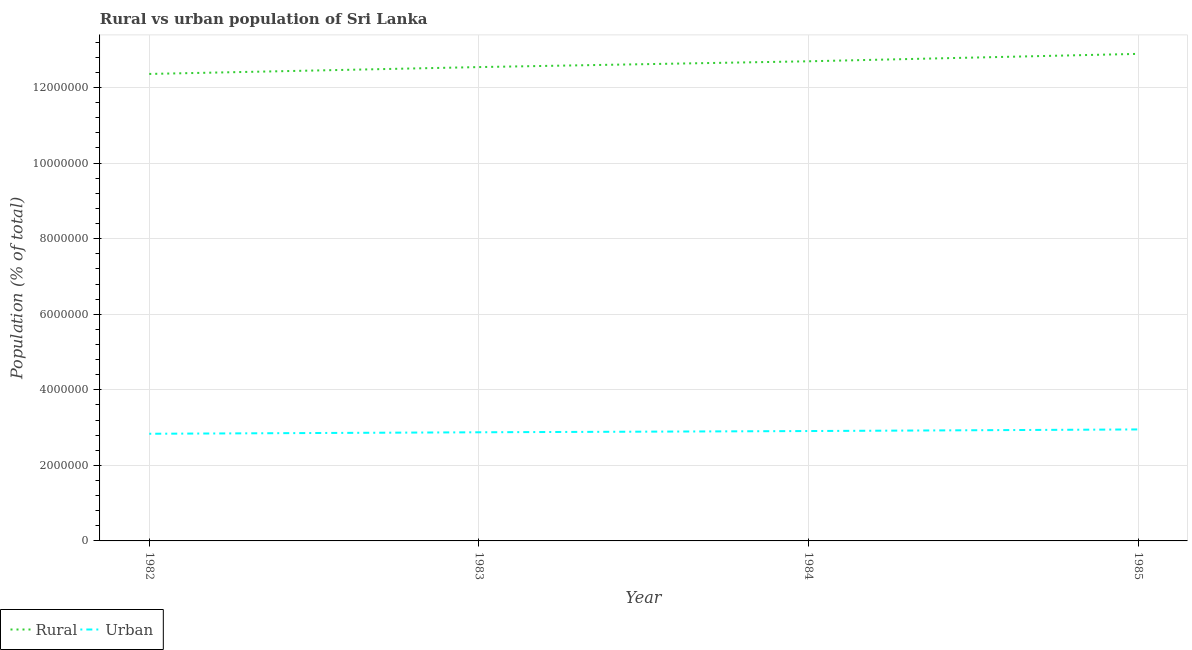Does the line corresponding to urban population density intersect with the line corresponding to rural population density?
Keep it short and to the point. No. What is the rural population density in 1983?
Give a very brief answer. 1.25e+07. Across all years, what is the maximum urban population density?
Make the answer very short. 2.95e+06. Across all years, what is the minimum rural population density?
Ensure brevity in your answer.  1.24e+07. In which year was the rural population density maximum?
Your response must be concise. 1985. What is the total rural population density in the graph?
Your response must be concise. 5.05e+07. What is the difference between the urban population density in 1982 and that in 1983?
Offer a terse response. -3.94e+04. What is the difference between the rural population density in 1985 and the urban population density in 1984?
Ensure brevity in your answer.  9.98e+06. What is the average rural population density per year?
Ensure brevity in your answer.  1.26e+07. In the year 1984, what is the difference between the urban population density and rural population density?
Your response must be concise. -9.79e+06. What is the ratio of the rural population density in 1982 to that in 1983?
Offer a very short reply. 0.99. Is the rural population density in 1983 less than that in 1985?
Provide a succinct answer. Yes. Is the difference between the rural population density in 1983 and 1985 greater than the difference between the urban population density in 1983 and 1985?
Provide a succinct answer. No. What is the difference between the highest and the second highest urban population density?
Offer a very short reply. 4.26e+04. What is the difference between the highest and the lowest urban population density?
Your answer should be compact. 1.15e+05. In how many years, is the urban population density greater than the average urban population density taken over all years?
Give a very brief answer. 2. Does the rural population density monotonically increase over the years?
Provide a short and direct response. Yes. Is the rural population density strictly greater than the urban population density over the years?
Your answer should be very brief. Yes. Is the urban population density strictly less than the rural population density over the years?
Your response must be concise. Yes. How many lines are there?
Your answer should be very brief. 2. How many years are there in the graph?
Keep it short and to the point. 4. Where does the legend appear in the graph?
Provide a short and direct response. Bottom left. How many legend labels are there?
Offer a terse response. 2. How are the legend labels stacked?
Provide a succinct answer. Horizontal. What is the title of the graph?
Offer a terse response. Rural vs urban population of Sri Lanka. What is the label or title of the Y-axis?
Give a very brief answer. Population (% of total). What is the Population (% of total) of Rural in 1982?
Provide a succinct answer. 1.24e+07. What is the Population (% of total) of Urban in 1982?
Provide a succinct answer. 2.84e+06. What is the Population (% of total) in Rural in 1983?
Make the answer very short. 1.25e+07. What is the Population (% of total) of Urban in 1983?
Provide a short and direct response. 2.88e+06. What is the Population (% of total) in Rural in 1984?
Give a very brief answer. 1.27e+07. What is the Population (% of total) of Urban in 1984?
Offer a terse response. 2.91e+06. What is the Population (% of total) in Rural in 1985?
Offer a very short reply. 1.29e+07. What is the Population (% of total) of Urban in 1985?
Provide a succinct answer. 2.95e+06. Across all years, what is the maximum Population (% of total) of Rural?
Your answer should be very brief. 1.29e+07. Across all years, what is the maximum Population (% of total) of Urban?
Ensure brevity in your answer.  2.95e+06. Across all years, what is the minimum Population (% of total) in Rural?
Provide a succinct answer. 1.24e+07. Across all years, what is the minimum Population (% of total) of Urban?
Your answer should be compact. 2.84e+06. What is the total Population (% of total) of Rural in the graph?
Your answer should be very brief. 5.05e+07. What is the total Population (% of total) in Urban in the graph?
Offer a terse response. 1.16e+07. What is the difference between the Population (% of total) in Rural in 1982 and that in 1983?
Give a very brief answer. -1.82e+05. What is the difference between the Population (% of total) in Urban in 1982 and that in 1983?
Keep it short and to the point. -3.94e+04. What is the difference between the Population (% of total) in Rural in 1982 and that in 1984?
Your response must be concise. -3.35e+05. What is the difference between the Population (% of total) in Urban in 1982 and that in 1984?
Offer a very short reply. -7.21e+04. What is the difference between the Population (% of total) of Rural in 1982 and that in 1985?
Give a very brief answer. -5.31e+05. What is the difference between the Population (% of total) in Urban in 1982 and that in 1985?
Your answer should be compact. -1.15e+05. What is the difference between the Population (% of total) of Rural in 1983 and that in 1984?
Your response must be concise. -1.53e+05. What is the difference between the Population (% of total) of Urban in 1983 and that in 1984?
Give a very brief answer. -3.27e+04. What is the difference between the Population (% of total) of Rural in 1983 and that in 1985?
Offer a very short reply. -3.50e+05. What is the difference between the Population (% of total) in Urban in 1983 and that in 1985?
Offer a terse response. -7.53e+04. What is the difference between the Population (% of total) of Rural in 1984 and that in 1985?
Offer a terse response. -1.96e+05. What is the difference between the Population (% of total) of Urban in 1984 and that in 1985?
Make the answer very short. -4.26e+04. What is the difference between the Population (% of total) of Rural in 1982 and the Population (% of total) of Urban in 1983?
Make the answer very short. 9.48e+06. What is the difference between the Population (% of total) in Rural in 1982 and the Population (% of total) in Urban in 1984?
Provide a short and direct response. 9.45e+06. What is the difference between the Population (% of total) in Rural in 1982 and the Population (% of total) in Urban in 1985?
Give a very brief answer. 9.41e+06. What is the difference between the Population (% of total) of Rural in 1983 and the Population (% of total) of Urban in 1984?
Ensure brevity in your answer.  9.63e+06. What is the difference between the Population (% of total) in Rural in 1983 and the Population (% of total) in Urban in 1985?
Offer a very short reply. 9.59e+06. What is the difference between the Population (% of total) in Rural in 1984 and the Population (% of total) in Urban in 1985?
Offer a terse response. 9.74e+06. What is the average Population (% of total) in Rural per year?
Ensure brevity in your answer.  1.26e+07. What is the average Population (% of total) in Urban per year?
Give a very brief answer. 2.89e+06. In the year 1982, what is the difference between the Population (% of total) of Rural and Population (% of total) of Urban?
Offer a terse response. 9.52e+06. In the year 1983, what is the difference between the Population (% of total) of Rural and Population (% of total) of Urban?
Your response must be concise. 9.67e+06. In the year 1984, what is the difference between the Population (% of total) of Rural and Population (% of total) of Urban?
Make the answer very short. 9.79e+06. In the year 1985, what is the difference between the Population (% of total) of Rural and Population (% of total) of Urban?
Ensure brevity in your answer.  9.94e+06. What is the ratio of the Population (% of total) in Rural in 1982 to that in 1983?
Your answer should be compact. 0.99. What is the ratio of the Population (% of total) in Urban in 1982 to that in 1983?
Keep it short and to the point. 0.99. What is the ratio of the Population (% of total) in Rural in 1982 to that in 1984?
Ensure brevity in your answer.  0.97. What is the ratio of the Population (% of total) in Urban in 1982 to that in 1984?
Keep it short and to the point. 0.98. What is the ratio of the Population (% of total) in Rural in 1982 to that in 1985?
Offer a very short reply. 0.96. What is the ratio of the Population (% of total) in Urban in 1982 to that in 1985?
Your answer should be very brief. 0.96. What is the ratio of the Population (% of total) in Rural in 1983 to that in 1984?
Your response must be concise. 0.99. What is the ratio of the Population (% of total) in Rural in 1983 to that in 1985?
Offer a very short reply. 0.97. What is the ratio of the Population (% of total) in Urban in 1983 to that in 1985?
Offer a very short reply. 0.97. What is the ratio of the Population (% of total) of Urban in 1984 to that in 1985?
Provide a succinct answer. 0.99. What is the difference between the highest and the second highest Population (% of total) of Rural?
Make the answer very short. 1.96e+05. What is the difference between the highest and the second highest Population (% of total) of Urban?
Your answer should be compact. 4.26e+04. What is the difference between the highest and the lowest Population (% of total) in Rural?
Ensure brevity in your answer.  5.31e+05. What is the difference between the highest and the lowest Population (% of total) of Urban?
Your answer should be compact. 1.15e+05. 